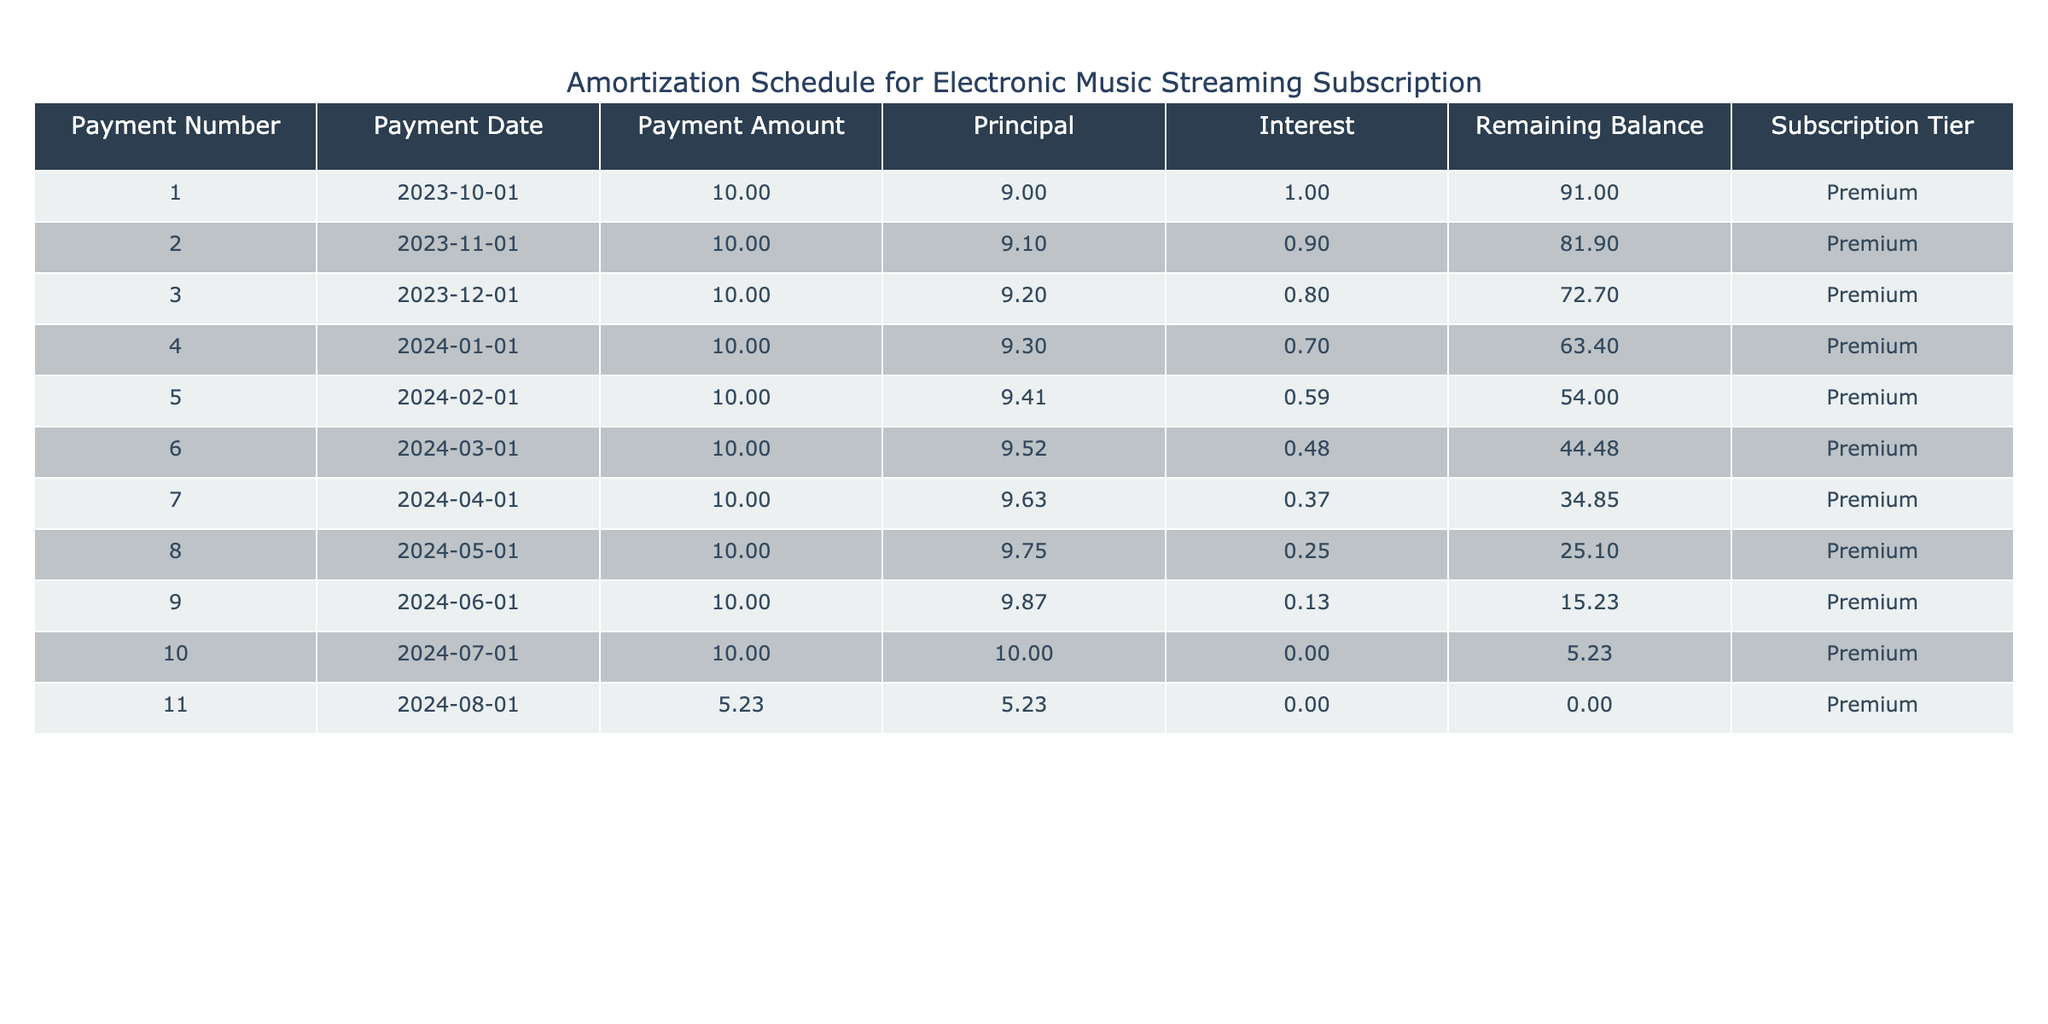What is the total payment amount made by the subscriber in the first three months? To find the total payment amount for the first three months, we need to sum the payment amounts for payments 1, 2, and 3. Each payment is $10.00, so the total is 10 + 10 + 10 = 30.
Answer: $30.00 What is the remaining balance after the 6th payment? The remaining balance after the 6th payment can be found in the 'Remaining Balance' column for payment number 6, which is $44.48.
Answer: $44.48 Did the principal amount paid increase with each successive payment? By examining the 'Principal' column, we can see the values are $9.00, $9.10, $9.20, etc., which consistently increase with each payment. Therefore, the statement is true.
Answer: Yes How much total interest did the subscriber pay over the course of the subscription? The interest amounts for each payment are: $1.00, $0.90, $0.80, $0.70, $0.59, $0.48, $0.37, $0.25, $0.13, $0.00, and $0.00. Adding these gives a total interest of 1.00 + 0.90 + 0.80 + 0.70 + 0.59 + 0.48 + 0.37 + 0.25 + 0.13 + 0.00 + 0.00 = $5.22.
Answer: $5.22 What was the payment amount for the last payment? The last payment amount can be found in the 'Payment Amount' column for payment number 11, which is $5.23.
Answer: $5.23 What is the change in the remaining balance from payment 4 to payment 10? To find the change, we take the remaining balance after payment 4, which is $63.40, and subtract the remaining balance after payment 10, which is $5.23. The difference is 63.40 - 5.23 = $58.17.
Answer: $58.17 